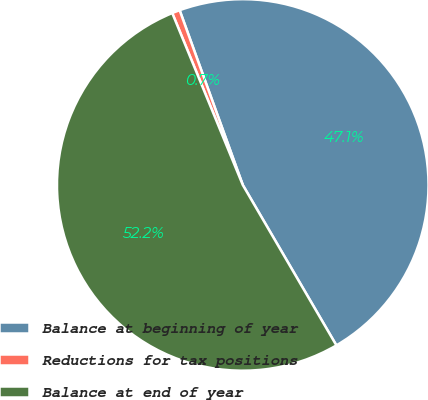Convert chart. <chart><loc_0><loc_0><loc_500><loc_500><pie_chart><fcel>Balance at beginning of year<fcel>Reductions for tax positions<fcel>Balance at end of year<nl><fcel>47.11%<fcel>0.68%<fcel>52.21%<nl></chart> 